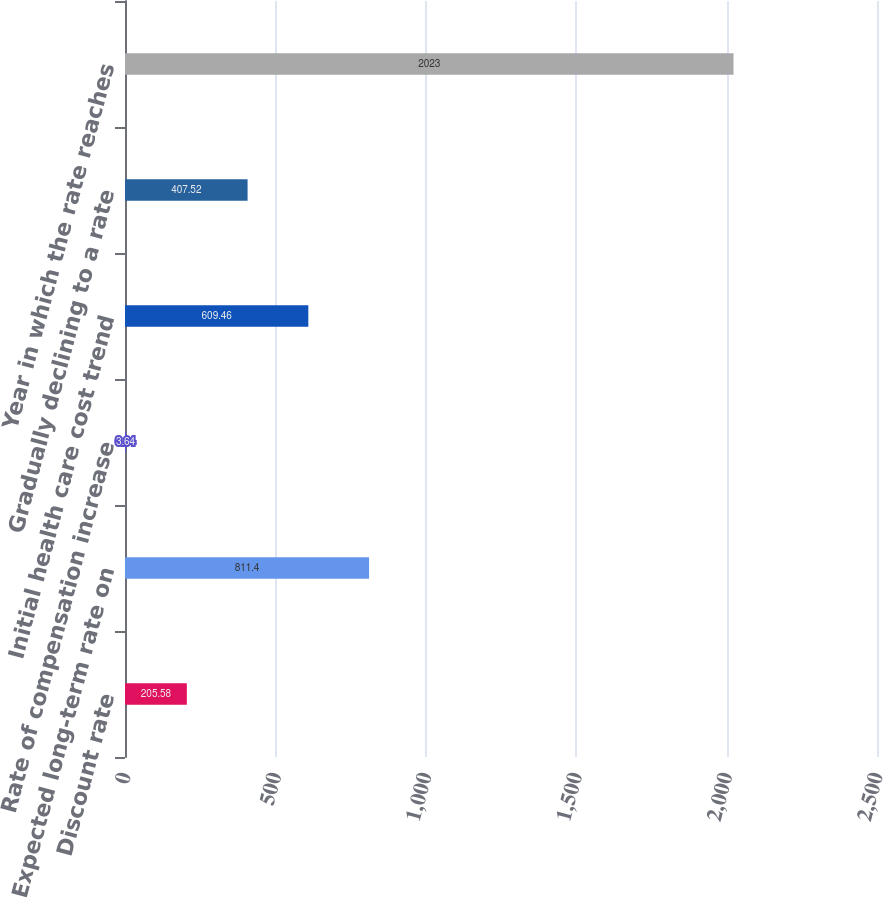<chart> <loc_0><loc_0><loc_500><loc_500><bar_chart><fcel>Discount rate<fcel>Expected long-term rate on<fcel>Rate of compensation increase<fcel>Initial health care cost trend<fcel>Gradually declining to a rate<fcel>Year in which the rate reaches<nl><fcel>205.58<fcel>811.4<fcel>3.64<fcel>609.46<fcel>407.52<fcel>2023<nl></chart> 